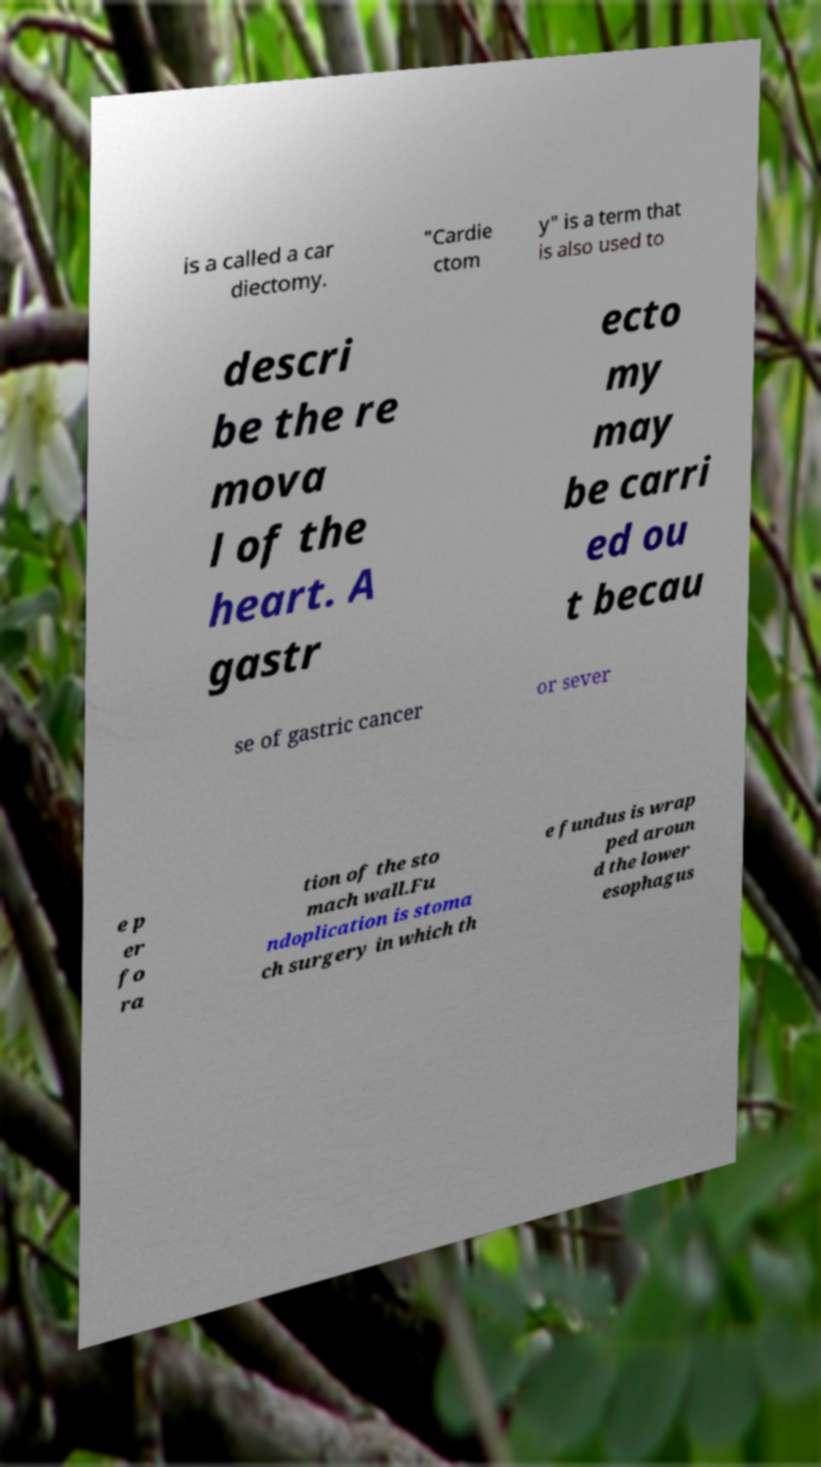Can you read and provide the text displayed in the image?This photo seems to have some interesting text. Can you extract and type it out for me? is a called a car diectomy. "Cardie ctom y" is a term that is also used to descri be the re mova l of the heart. A gastr ecto my may be carri ed ou t becau se of gastric cancer or sever e p er fo ra tion of the sto mach wall.Fu ndoplication is stoma ch surgery in which th e fundus is wrap ped aroun d the lower esophagus 